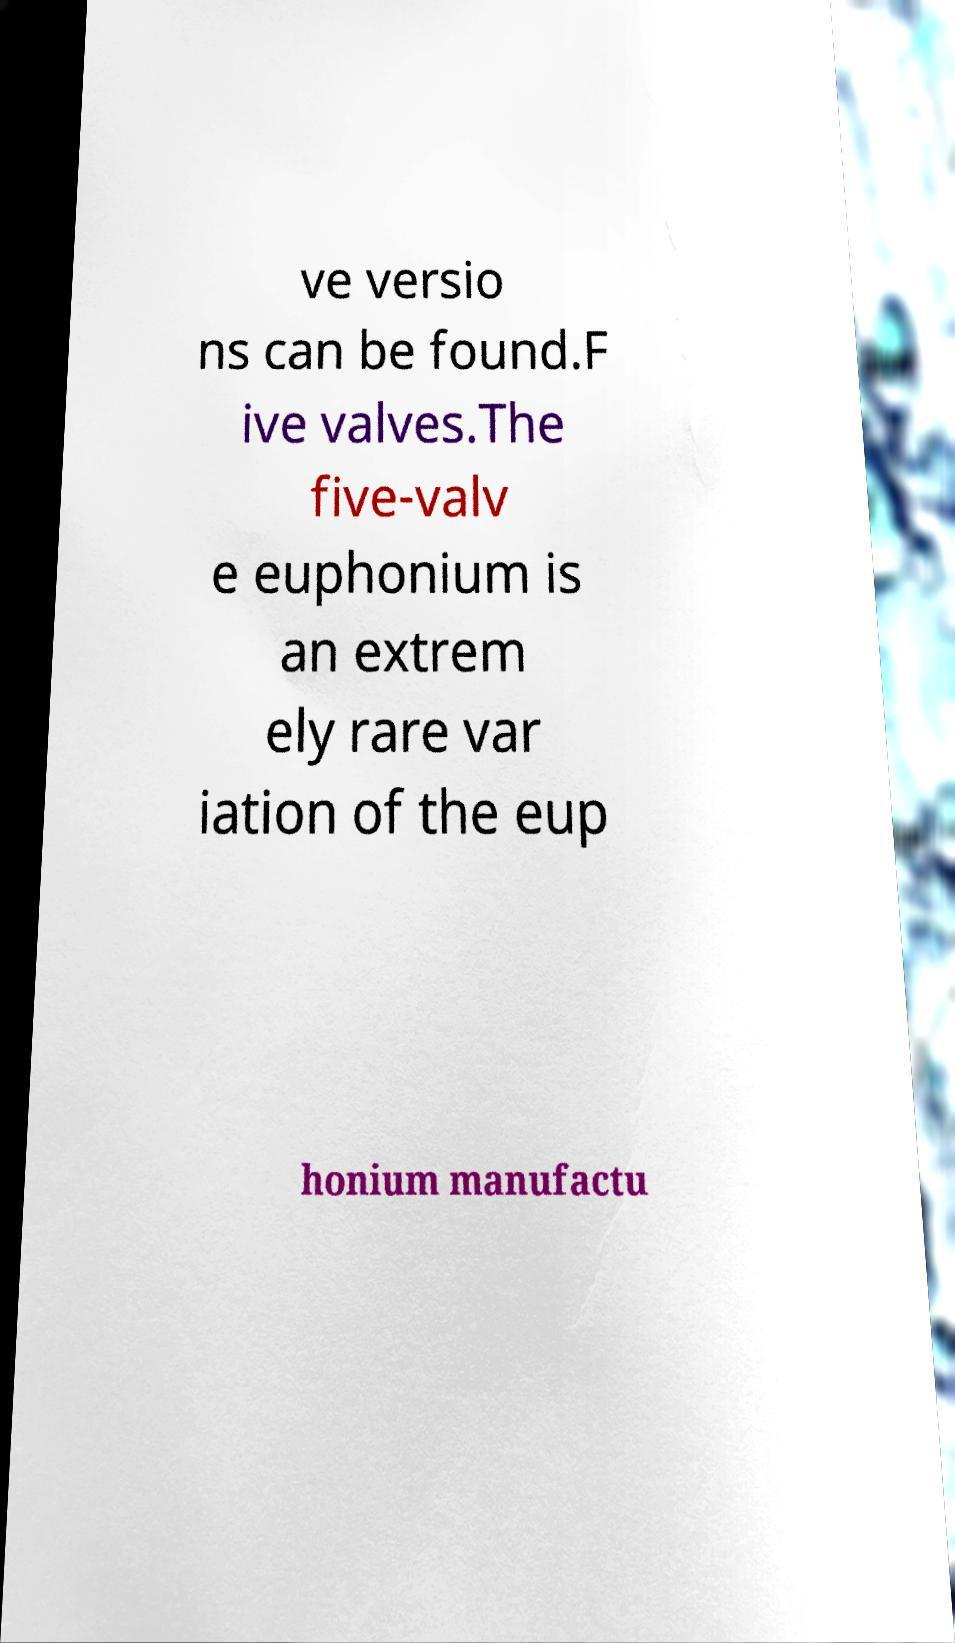I need the written content from this picture converted into text. Can you do that? ve versio ns can be found.F ive valves.The five-valv e euphonium is an extrem ely rare var iation of the eup honium manufactu 